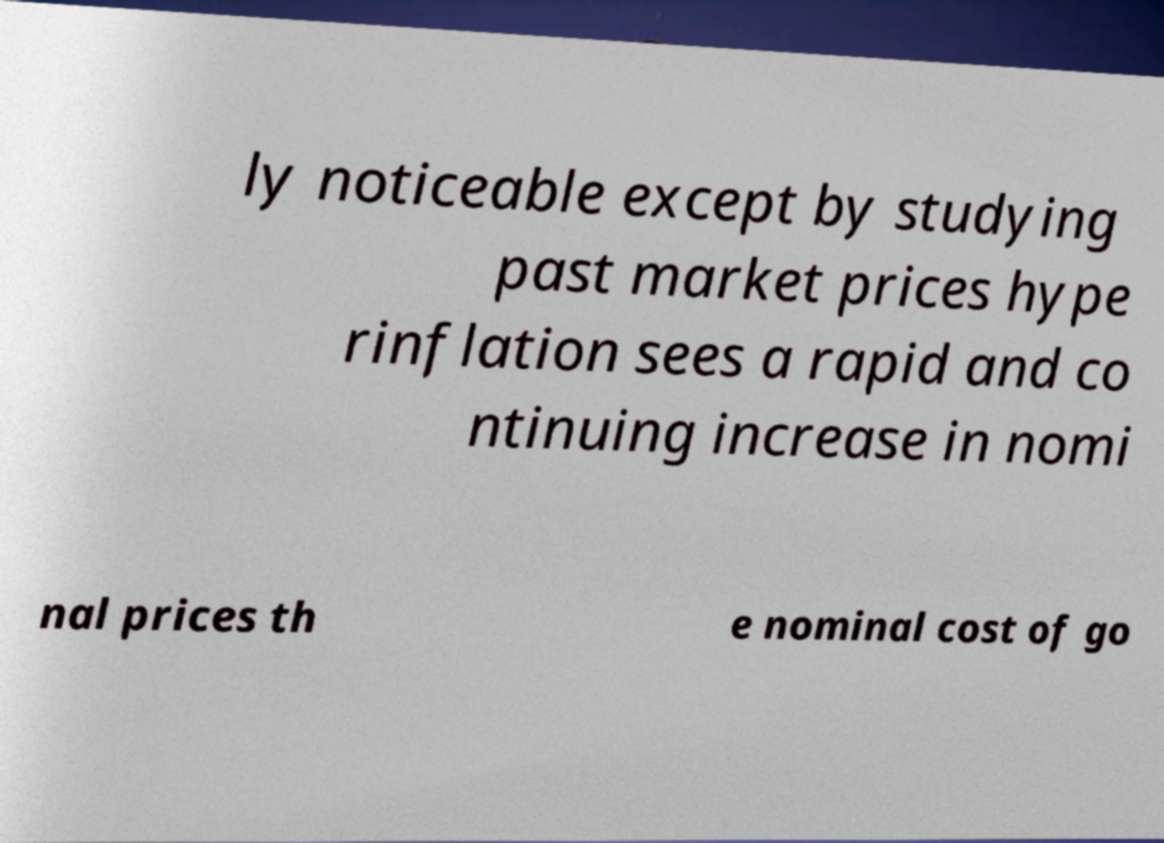Please read and relay the text visible in this image. What does it say? ly noticeable except by studying past market prices hype rinflation sees a rapid and co ntinuing increase in nomi nal prices th e nominal cost of go 